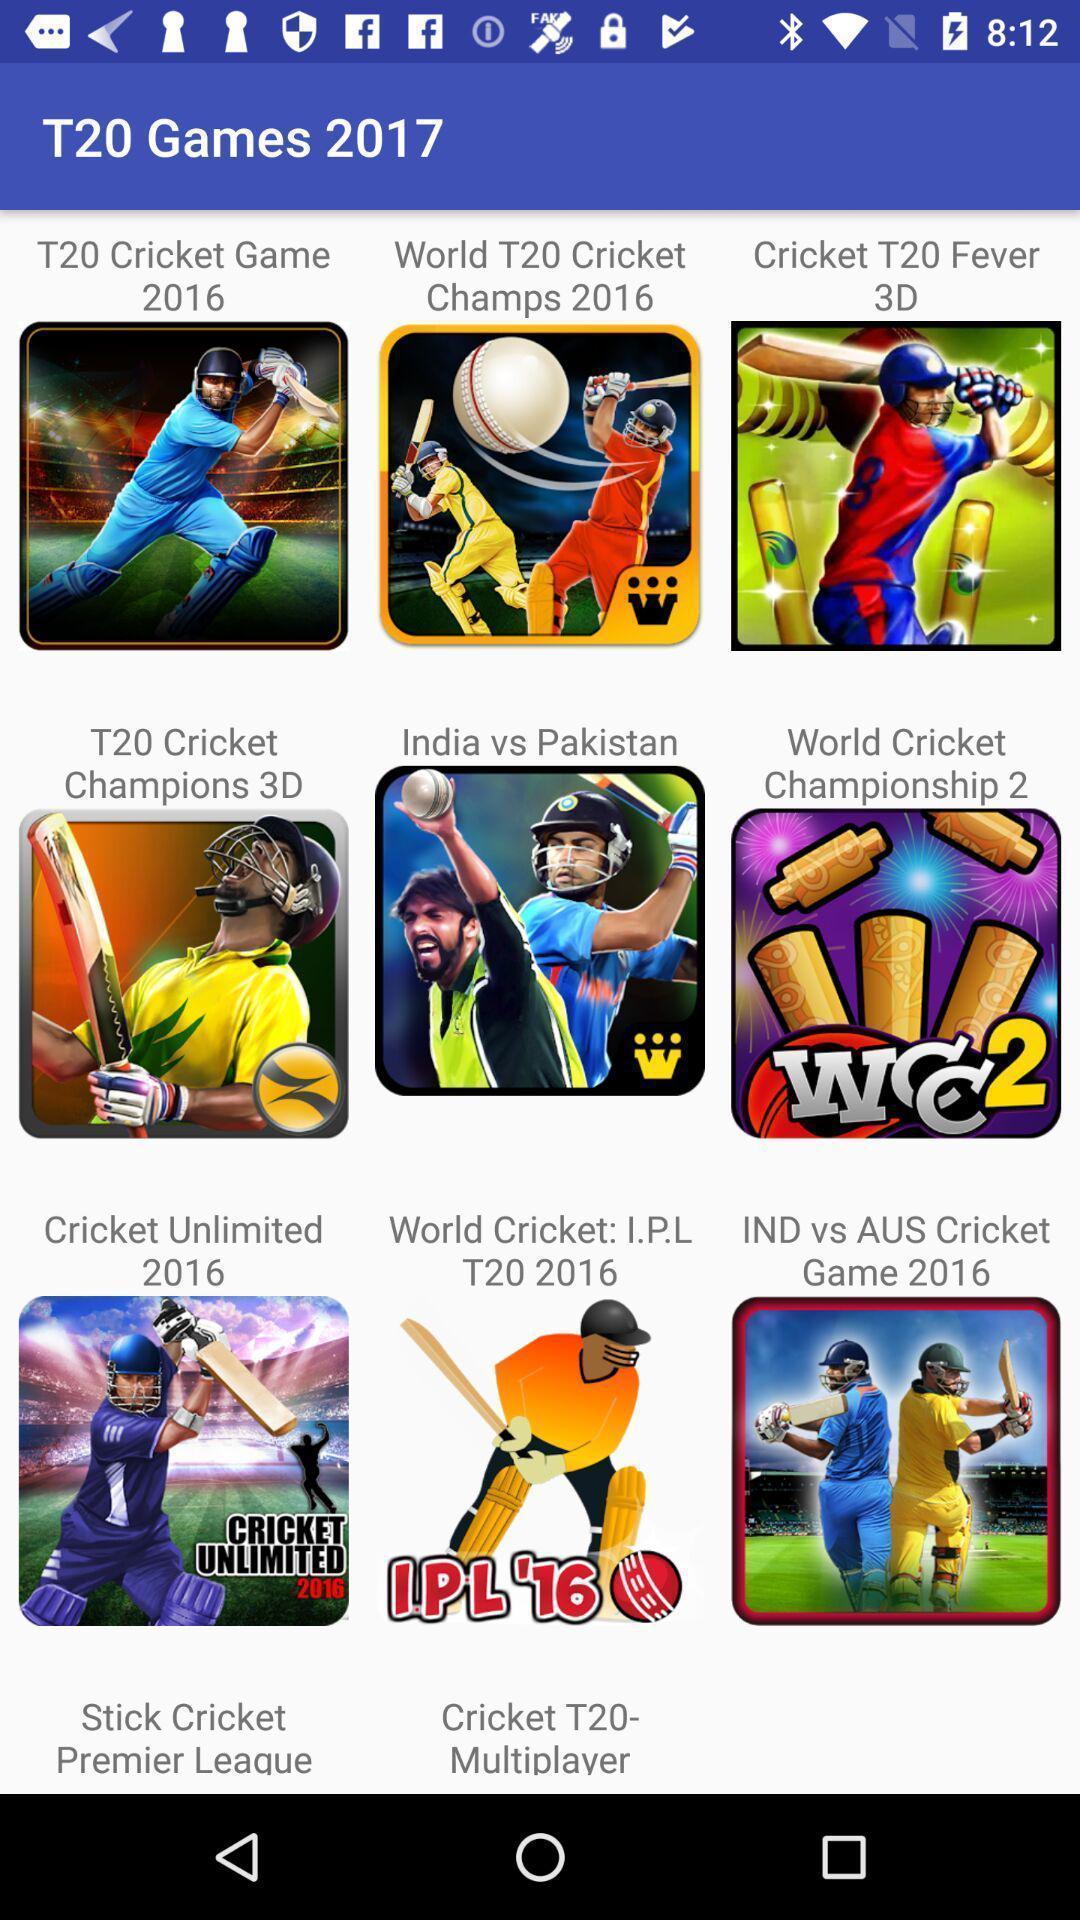Explain what's happening in this screen capture. Page showing multiple games. 